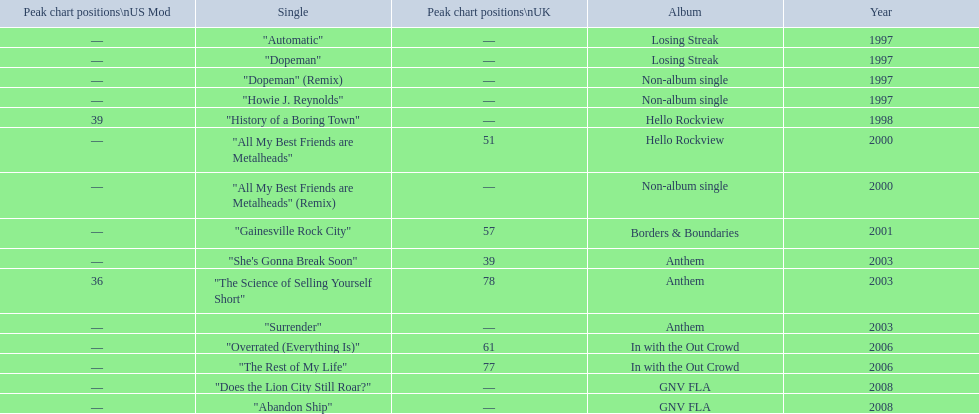Which album had the single automatic? Losing Streak. 